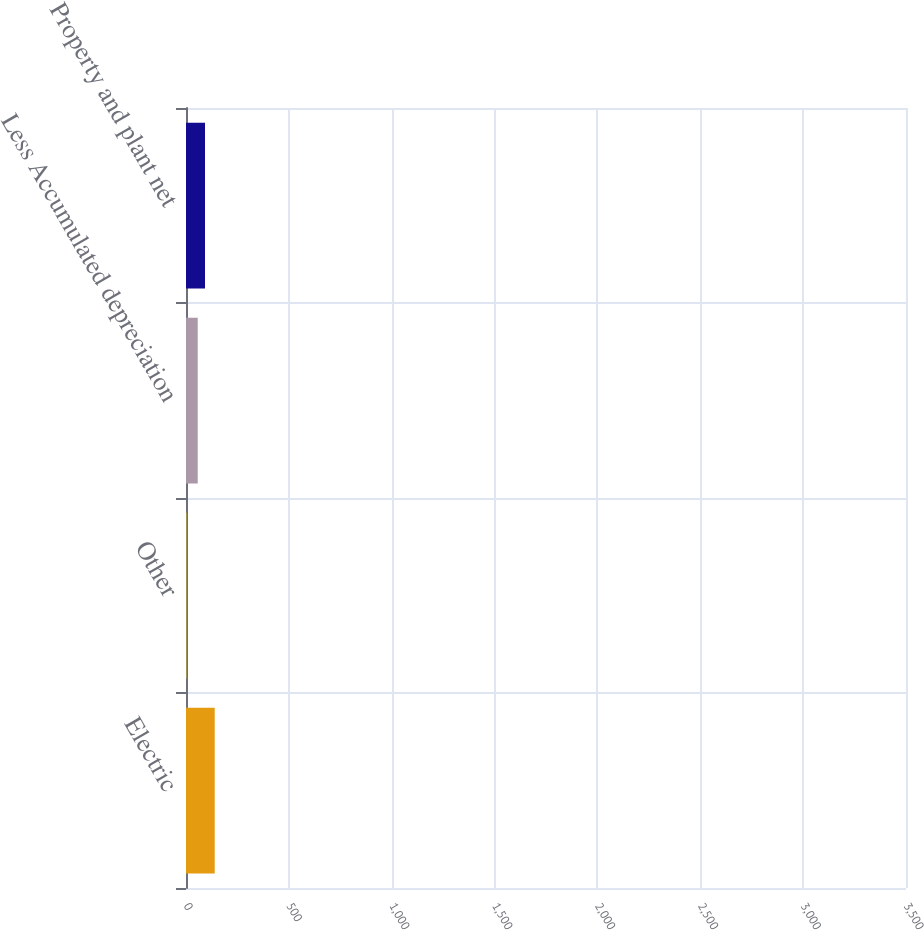<chart> <loc_0><loc_0><loc_500><loc_500><bar_chart><fcel>Electric<fcel>Other<fcel>Less Accumulated depreciation<fcel>Property and plant net<nl><fcel>3370<fcel>39<fcel>1377<fcel>2231<nl></chart> 